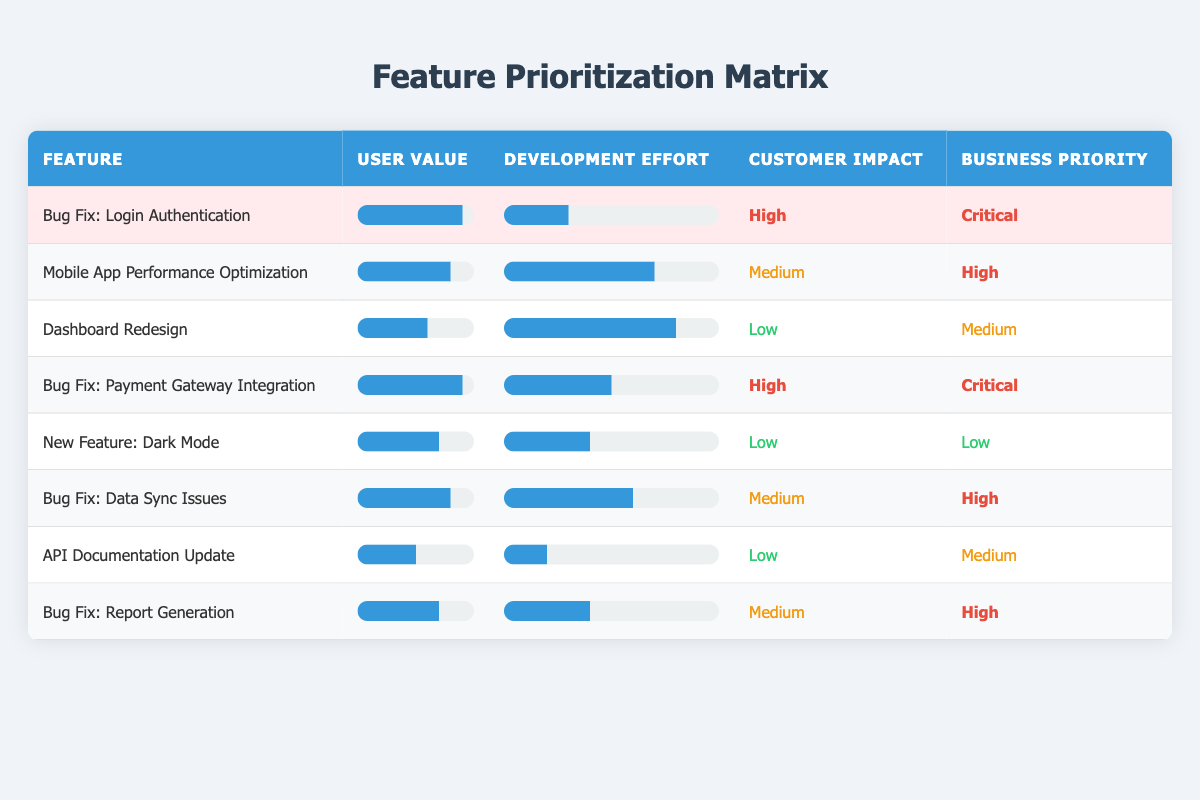What is the user value of the feature "Bug Fix: Login Authentication"? The table indicates the user value for "Bug Fix: Login Authentication" is specified in the second column, which shows a value of 9.
Answer: 9 Which feature has the highest customer impact? By reviewing the customer impact column, both "Bug Fix: Login Authentication" and "Bug Fix: Payment Gateway Integration" are marked as "High." Therefore, these two features share the highest customer impact.
Answer: Bug Fix: Login Authentication and Bug Fix: Payment Gateway Integration What is the development effort associated with the feature "API Documentation Update"? In the table under the development effort column, the value associated with "API Documentation Update" is specified, which is 2.
Answer: 2 Which bug fix feature has the lowest user value? Examining the user value column across all bug fix features, "API Documentation Update" has the lowest value of 5, even though it is not specifically labeled as a bug fix, it is noted for improvement purposes.
Answer: Bug Fix: Data Sync Issues Is the business priority for "New Feature: Dark Mode" critical? Checking the business priority column, "New Feature: Dark Mode" is categorized as "Low," which confirms that it is not critical.
Answer: No What is the average user value of all features listed? To calculate the average user value, sum the user values (9 + 8 + 6 + 9 + 7 + 8 + 5 + 7 = 59) and divide by the total number of features (8). The average is 59/8 = 7.375.
Answer: 7.375 Which feature requires the highest development effort? The development effort column shows that "Dashboard Redesign" has the highest development effort with a value of 8, indicating that it is the most resource-intensive feature.
Answer: Dashboard Redesign How many features are categorized as having a "High" business priority? By counting the entries in the business priority column marked as "High," we find there are four features: "Mobile App Performance Optimization," "Bug Fix: Payment Gateway Integration," "Bug Fix: Data Sync Issues," and "Bug Fix: Report Generation."
Answer: 4 What is the total user value of all "Bug Fix" features? By summing the user values of each bug fix feature (9 for "Login Authentication," 9 for "Payment Gateway Integration," 8 for "Data Sync Issues," and 7 for "Report Generation"), we calculate (9 + 9 + 8 + 7 = 33).
Answer: 33 